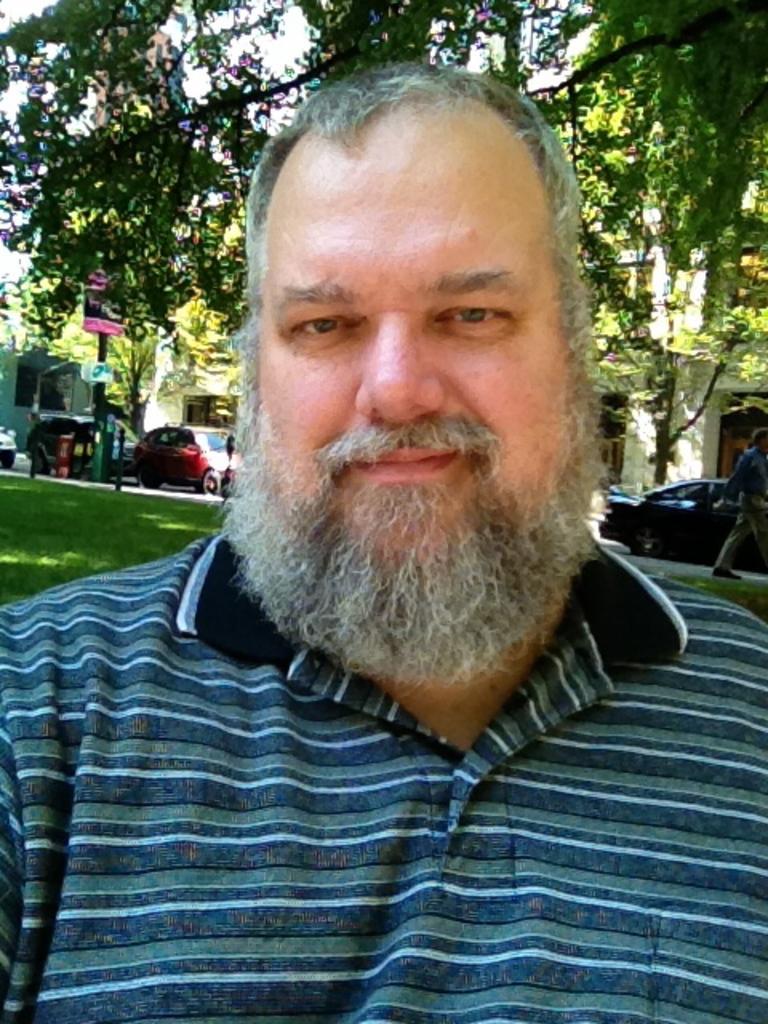Please provide a concise description of this image. In this picture I can observe a man in the middle of the picture. He is wearing T shirt. In the background I can observe some cars on the road and there are some trees. 